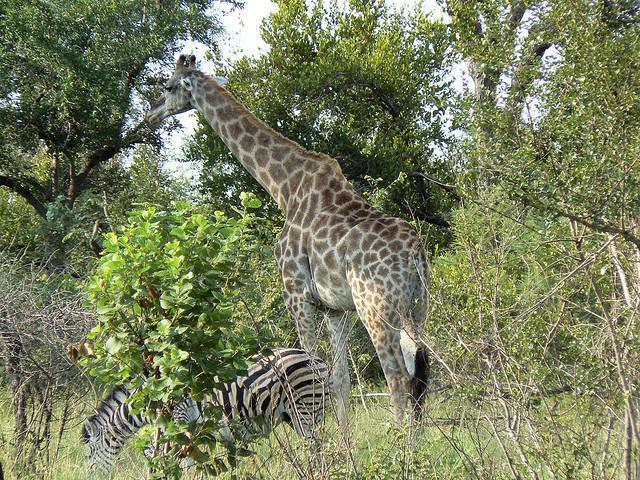How many zebra are walking through the field?
Give a very brief answer. 1. How many zebras are there?
Give a very brief answer. 2. How many buses are there?
Give a very brief answer. 0. 